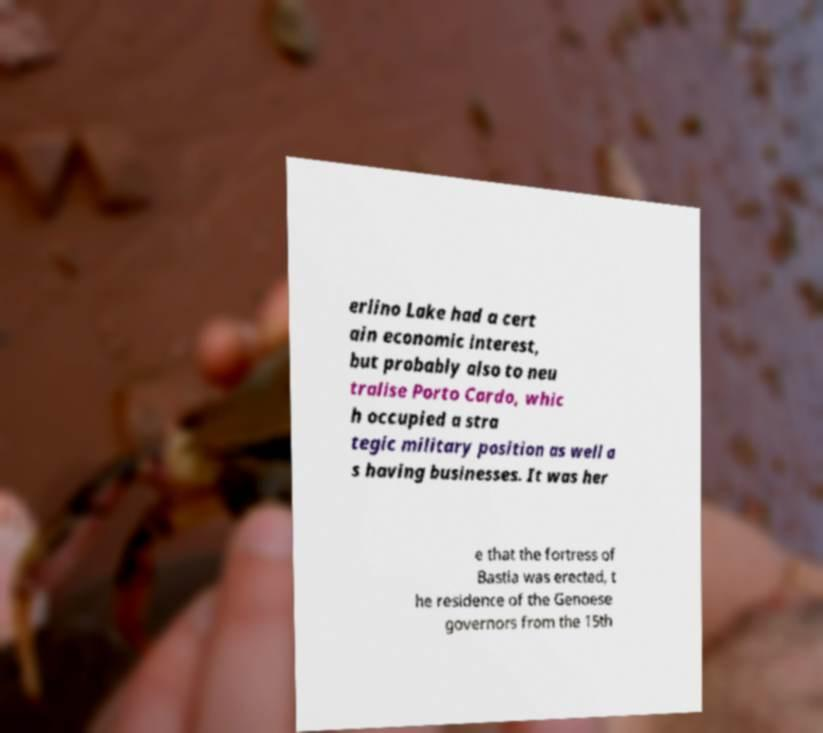Please identify and transcribe the text found in this image. erlino Lake had a cert ain economic interest, but probably also to neu tralise Porto Cardo, whic h occupied a stra tegic military position as well a s having businesses. It was her e that the fortress of Bastia was erected, t he residence of the Genoese governors from the 15th 